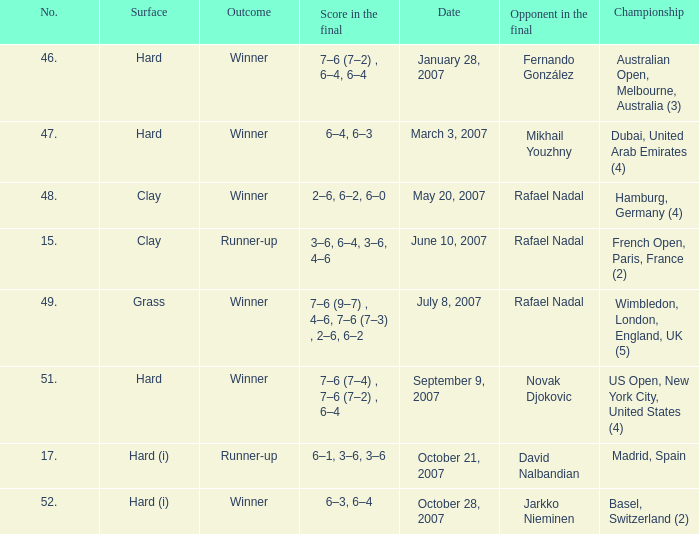The score in the final is 2–6, 6–2, 6–0, on what surface? Clay. 